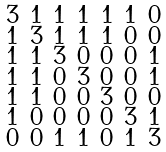Convert formula to latex. <formula><loc_0><loc_0><loc_500><loc_500>\begin{smallmatrix} 3 & 1 & 1 & 1 & 1 & 1 & 0 \\ 1 & 3 & 1 & 1 & 1 & 0 & 0 \\ 1 & 1 & 3 & 0 & 0 & 0 & 1 \\ 1 & 1 & 0 & 3 & 0 & 0 & 1 \\ 1 & 1 & 0 & 0 & 3 & 0 & 0 \\ 1 & 0 & 0 & 0 & 0 & 3 & 1 \\ 0 & 0 & 1 & 1 & 0 & 1 & 3 \end{smallmatrix}</formula> 